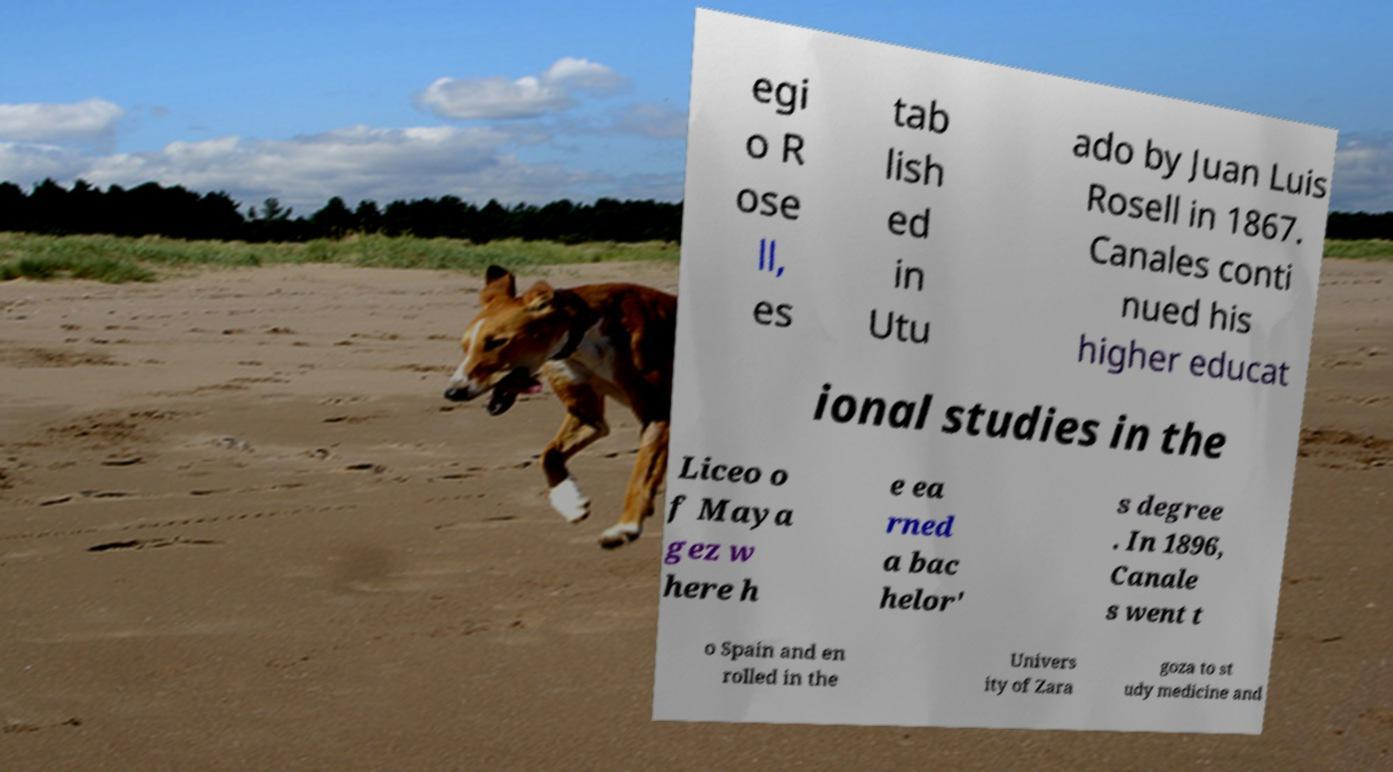For documentation purposes, I need the text within this image transcribed. Could you provide that? egi o R ose ll, es tab lish ed in Utu ado by Juan Luis Rosell in 1867. Canales conti nued his higher educat ional studies in the Liceo o f Maya gez w here h e ea rned a bac helor' s degree . In 1896, Canale s went t o Spain and en rolled in the Univers ity of Zara goza to st udy medicine and 